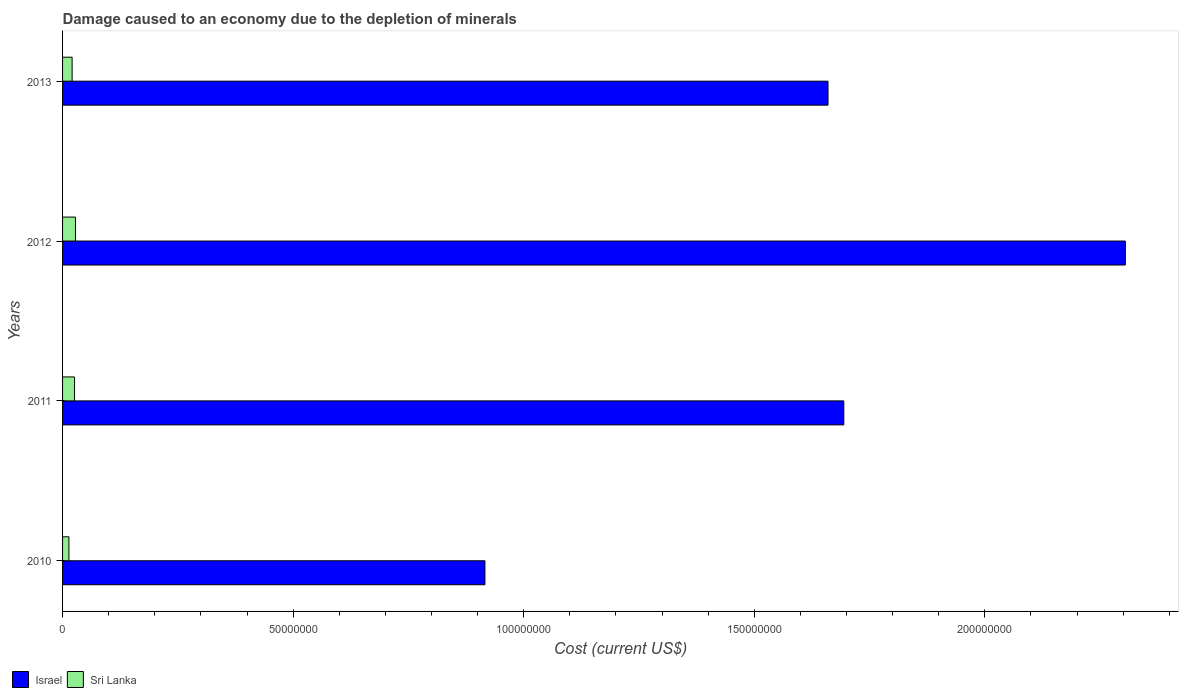How many groups of bars are there?
Keep it short and to the point. 4. How many bars are there on the 2nd tick from the top?
Offer a terse response. 2. How many bars are there on the 1st tick from the bottom?
Provide a succinct answer. 2. What is the label of the 3rd group of bars from the top?
Offer a terse response. 2011. In how many cases, is the number of bars for a given year not equal to the number of legend labels?
Provide a short and direct response. 0. What is the cost of damage caused due to the depletion of minerals in Israel in 2010?
Ensure brevity in your answer.  9.16e+07. Across all years, what is the maximum cost of damage caused due to the depletion of minerals in Sri Lanka?
Provide a succinct answer. 2.80e+06. Across all years, what is the minimum cost of damage caused due to the depletion of minerals in Sri Lanka?
Offer a terse response. 1.38e+06. What is the total cost of damage caused due to the depletion of minerals in Sri Lanka in the graph?
Keep it short and to the point. 8.84e+06. What is the difference between the cost of damage caused due to the depletion of minerals in Israel in 2010 and that in 2011?
Make the answer very short. -7.78e+07. What is the difference between the cost of damage caused due to the depletion of minerals in Israel in 2010 and the cost of damage caused due to the depletion of minerals in Sri Lanka in 2013?
Offer a very short reply. 8.95e+07. What is the average cost of damage caused due to the depletion of minerals in Israel per year?
Offer a terse response. 1.64e+08. In the year 2010, what is the difference between the cost of damage caused due to the depletion of minerals in Israel and cost of damage caused due to the depletion of minerals in Sri Lanka?
Offer a terse response. 9.02e+07. What is the ratio of the cost of damage caused due to the depletion of minerals in Sri Lanka in 2010 to that in 2012?
Your answer should be very brief. 0.49. Is the cost of damage caused due to the depletion of minerals in Sri Lanka in 2011 less than that in 2013?
Your answer should be very brief. No. What is the difference between the highest and the second highest cost of damage caused due to the depletion of minerals in Sri Lanka?
Make the answer very short. 2.01e+05. What is the difference between the highest and the lowest cost of damage caused due to the depletion of minerals in Israel?
Offer a very short reply. 1.39e+08. In how many years, is the cost of damage caused due to the depletion of minerals in Sri Lanka greater than the average cost of damage caused due to the depletion of minerals in Sri Lanka taken over all years?
Offer a very short reply. 2. Is the sum of the cost of damage caused due to the depletion of minerals in Sri Lanka in 2010 and 2011 greater than the maximum cost of damage caused due to the depletion of minerals in Israel across all years?
Ensure brevity in your answer.  No. What does the 2nd bar from the top in 2013 represents?
Your answer should be very brief. Israel. What does the 2nd bar from the bottom in 2010 represents?
Your response must be concise. Sri Lanka. How many bars are there?
Your response must be concise. 8. Are all the bars in the graph horizontal?
Your response must be concise. Yes. How many years are there in the graph?
Offer a terse response. 4. What is the difference between two consecutive major ticks on the X-axis?
Ensure brevity in your answer.  5.00e+07. Does the graph contain any zero values?
Give a very brief answer. No. Does the graph contain grids?
Offer a very short reply. No. What is the title of the graph?
Keep it short and to the point. Damage caused to an economy due to the depletion of minerals. What is the label or title of the X-axis?
Give a very brief answer. Cost (current US$). What is the Cost (current US$) of Israel in 2010?
Your answer should be very brief. 9.16e+07. What is the Cost (current US$) in Sri Lanka in 2010?
Your response must be concise. 1.38e+06. What is the Cost (current US$) of Israel in 2011?
Your response must be concise. 1.69e+08. What is the Cost (current US$) in Sri Lanka in 2011?
Your answer should be compact. 2.60e+06. What is the Cost (current US$) in Israel in 2012?
Ensure brevity in your answer.  2.30e+08. What is the Cost (current US$) in Sri Lanka in 2012?
Offer a terse response. 2.80e+06. What is the Cost (current US$) of Israel in 2013?
Ensure brevity in your answer.  1.66e+08. What is the Cost (current US$) in Sri Lanka in 2013?
Ensure brevity in your answer.  2.07e+06. Across all years, what is the maximum Cost (current US$) in Israel?
Your response must be concise. 2.30e+08. Across all years, what is the maximum Cost (current US$) of Sri Lanka?
Your answer should be very brief. 2.80e+06. Across all years, what is the minimum Cost (current US$) in Israel?
Provide a succinct answer. 9.16e+07. Across all years, what is the minimum Cost (current US$) of Sri Lanka?
Your answer should be compact. 1.38e+06. What is the total Cost (current US$) of Israel in the graph?
Offer a terse response. 6.57e+08. What is the total Cost (current US$) of Sri Lanka in the graph?
Offer a very short reply. 8.84e+06. What is the difference between the Cost (current US$) of Israel in 2010 and that in 2011?
Provide a succinct answer. -7.78e+07. What is the difference between the Cost (current US$) in Sri Lanka in 2010 and that in 2011?
Your answer should be compact. -1.22e+06. What is the difference between the Cost (current US$) in Israel in 2010 and that in 2012?
Provide a succinct answer. -1.39e+08. What is the difference between the Cost (current US$) in Sri Lanka in 2010 and that in 2012?
Your response must be concise. -1.42e+06. What is the difference between the Cost (current US$) in Israel in 2010 and that in 2013?
Offer a terse response. -7.44e+07. What is the difference between the Cost (current US$) in Sri Lanka in 2010 and that in 2013?
Give a very brief answer. -6.96e+05. What is the difference between the Cost (current US$) of Israel in 2011 and that in 2012?
Give a very brief answer. -6.11e+07. What is the difference between the Cost (current US$) of Sri Lanka in 2011 and that in 2012?
Provide a succinct answer. -2.01e+05. What is the difference between the Cost (current US$) of Israel in 2011 and that in 2013?
Provide a short and direct response. 3.42e+06. What is the difference between the Cost (current US$) of Sri Lanka in 2011 and that in 2013?
Offer a terse response. 5.25e+05. What is the difference between the Cost (current US$) in Israel in 2012 and that in 2013?
Give a very brief answer. 6.45e+07. What is the difference between the Cost (current US$) of Sri Lanka in 2012 and that in 2013?
Your answer should be very brief. 7.26e+05. What is the difference between the Cost (current US$) in Israel in 2010 and the Cost (current US$) in Sri Lanka in 2011?
Your answer should be compact. 8.90e+07. What is the difference between the Cost (current US$) in Israel in 2010 and the Cost (current US$) in Sri Lanka in 2012?
Your answer should be compact. 8.88e+07. What is the difference between the Cost (current US$) of Israel in 2010 and the Cost (current US$) of Sri Lanka in 2013?
Give a very brief answer. 8.95e+07. What is the difference between the Cost (current US$) in Israel in 2011 and the Cost (current US$) in Sri Lanka in 2012?
Your response must be concise. 1.67e+08. What is the difference between the Cost (current US$) of Israel in 2011 and the Cost (current US$) of Sri Lanka in 2013?
Provide a succinct answer. 1.67e+08. What is the difference between the Cost (current US$) of Israel in 2012 and the Cost (current US$) of Sri Lanka in 2013?
Your response must be concise. 2.28e+08. What is the average Cost (current US$) of Israel per year?
Keep it short and to the point. 1.64e+08. What is the average Cost (current US$) of Sri Lanka per year?
Give a very brief answer. 2.21e+06. In the year 2010, what is the difference between the Cost (current US$) in Israel and Cost (current US$) in Sri Lanka?
Give a very brief answer. 9.02e+07. In the year 2011, what is the difference between the Cost (current US$) of Israel and Cost (current US$) of Sri Lanka?
Your response must be concise. 1.67e+08. In the year 2012, what is the difference between the Cost (current US$) in Israel and Cost (current US$) in Sri Lanka?
Offer a very short reply. 2.28e+08. In the year 2013, what is the difference between the Cost (current US$) of Israel and Cost (current US$) of Sri Lanka?
Offer a very short reply. 1.64e+08. What is the ratio of the Cost (current US$) of Israel in 2010 to that in 2011?
Keep it short and to the point. 0.54. What is the ratio of the Cost (current US$) in Sri Lanka in 2010 to that in 2011?
Your response must be concise. 0.53. What is the ratio of the Cost (current US$) in Israel in 2010 to that in 2012?
Your answer should be compact. 0.4. What is the ratio of the Cost (current US$) in Sri Lanka in 2010 to that in 2012?
Make the answer very short. 0.49. What is the ratio of the Cost (current US$) in Israel in 2010 to that in 2013?
Ensure brevity in your answer.  0.55. What is the ratio of the Cost (current US$) of Sri Lanka in 2010 to that in 2013?
Provide a succinct answer. 0.66. What is the ratio of the Cost (current US$) in Israel in 2011 to that in 2012?
Provide a succinct answer. 0.74. What is the ratio of the Cost (current US$) of Sri Lanka in 2011 to that in 2012?
Make the answer very short. 0.93. What is the ratio of the Cost (current US$) of Israel in 2011 to that in 2013?
Provide a short and direct response. 1.02. What is the ratio of the Cost (current US$) in Sri Lanka in 2011 to that in 2013?
Provide a succinct answer. 1.25. What is the ratio of the Cost (current US$) of Israel in 2012 to that in 2013?
Keep it short and to the point. 1.39. What is the ratio of the Cost (current US$) in Sri Lanka in 2012 to that in 2013?
Offer a terse response. 1.35. What is the difference between the highest and the second highest Cost (current US$) in Israel?
Your response must be concise. 6.11e+07. What is the difference between the highest and the second highest Cost (current US$) in Sri Lanka?
Keep it short and to the point. 2.01e+05. What is the difference between the highest and the lowest Cost (current US$) in Israel?
Your answer should be very brief. 1.39e+08. What is the difference between the highest and the lowest Cost (current US$) of Sri Lanka?
Offer a terse response. 1.42e+06. 